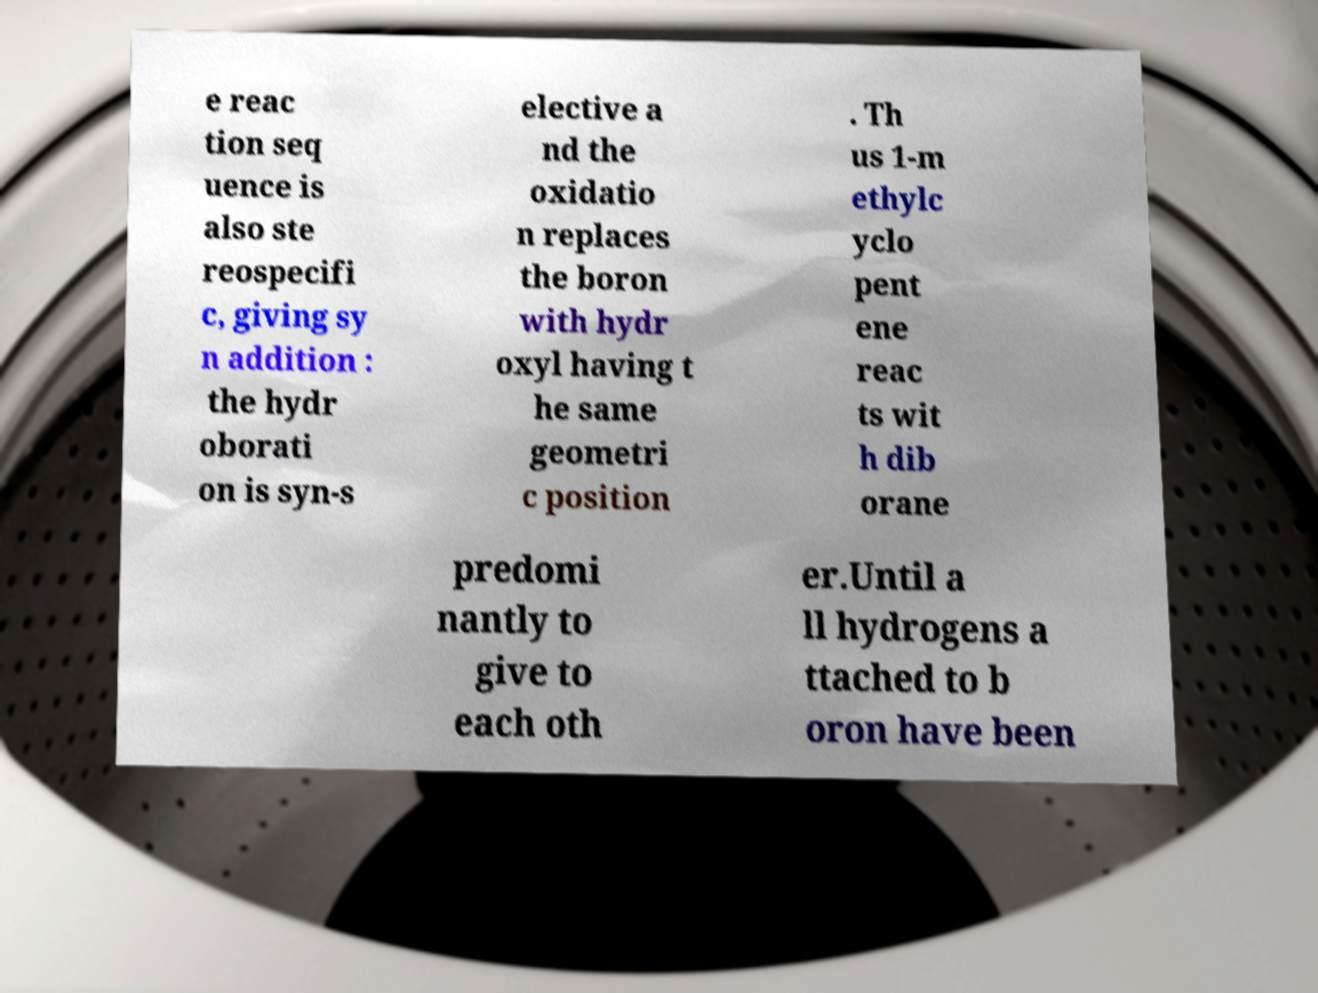Can you accurately transcribe the text from the provided image for me? e reac tion seq uence is also ste reospecifi c, giving sy n addition : the hydr oborati on is syn-s elective a nd the oxidatio n replaces the boron with hydr oxyl having t he same geometri c position . Th us 1-m ethylc yclo pent ene reac ts wit h dib orane predomi nantly to give to each oth er.Until a ll hydrogens a ttached to b oron have been 